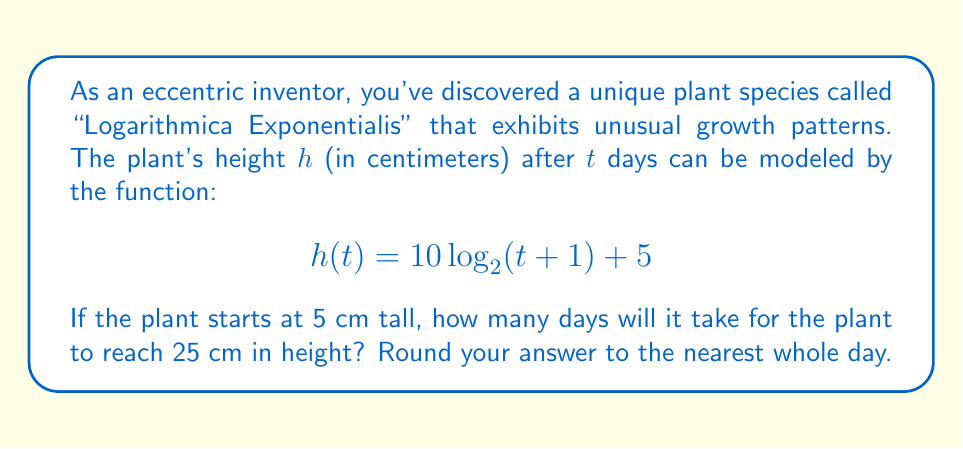What is the answer to this math problem? Let's approach this step-by-step:

1) We're given the height function: $h(t) = 10 \log_2(t+1) + 5$

2) We want to find $t$ when $h(t) = 25$ cm. So, let's set up the equation:

   $$25 = 10 \log_2(t+1) + 5$$

3) Subtract 5 from both sides:

   $$20 = 10 log_2(t+1)$$

4) Divide both sides by 10:

   $$2 = \log_2(t+1)$$

5) Now, we need to solve for $t$. We can do this by applying $2^x$ to both sides:

   $$2^2 = 2^{\log_2(t+1)}$$

6) Simplify the left side:

   $$4 = t+1$$

7) Subtract 1 from both sides:

   $$3 = t$$

Therefore, it will take 3 days for the plant to reach 25 cm in height.

To verify:
$$h(3) = 10 \log_2(3+1) + 5 = 10 \log_2(4) + 5 = 10 * 2 + 5 = 25$$

This confirms our solution.
Answer: 3 days 